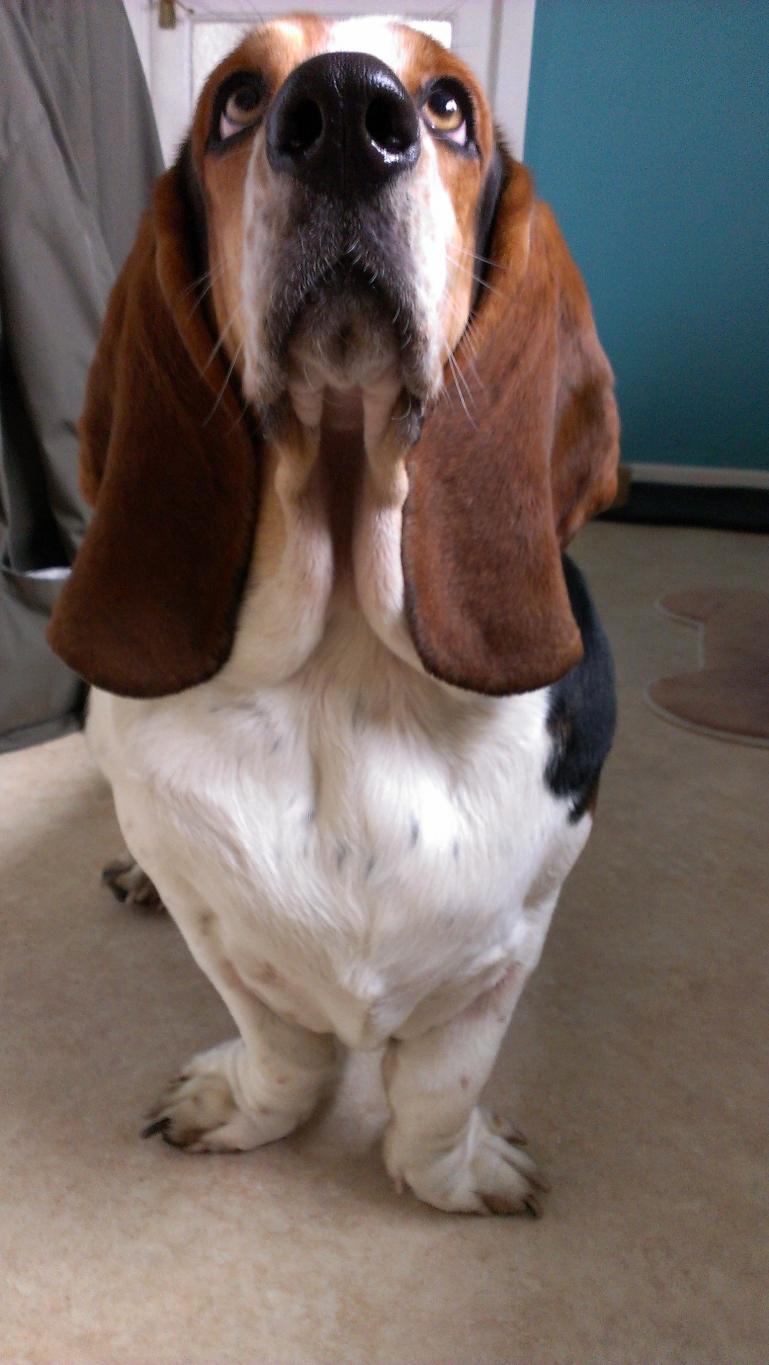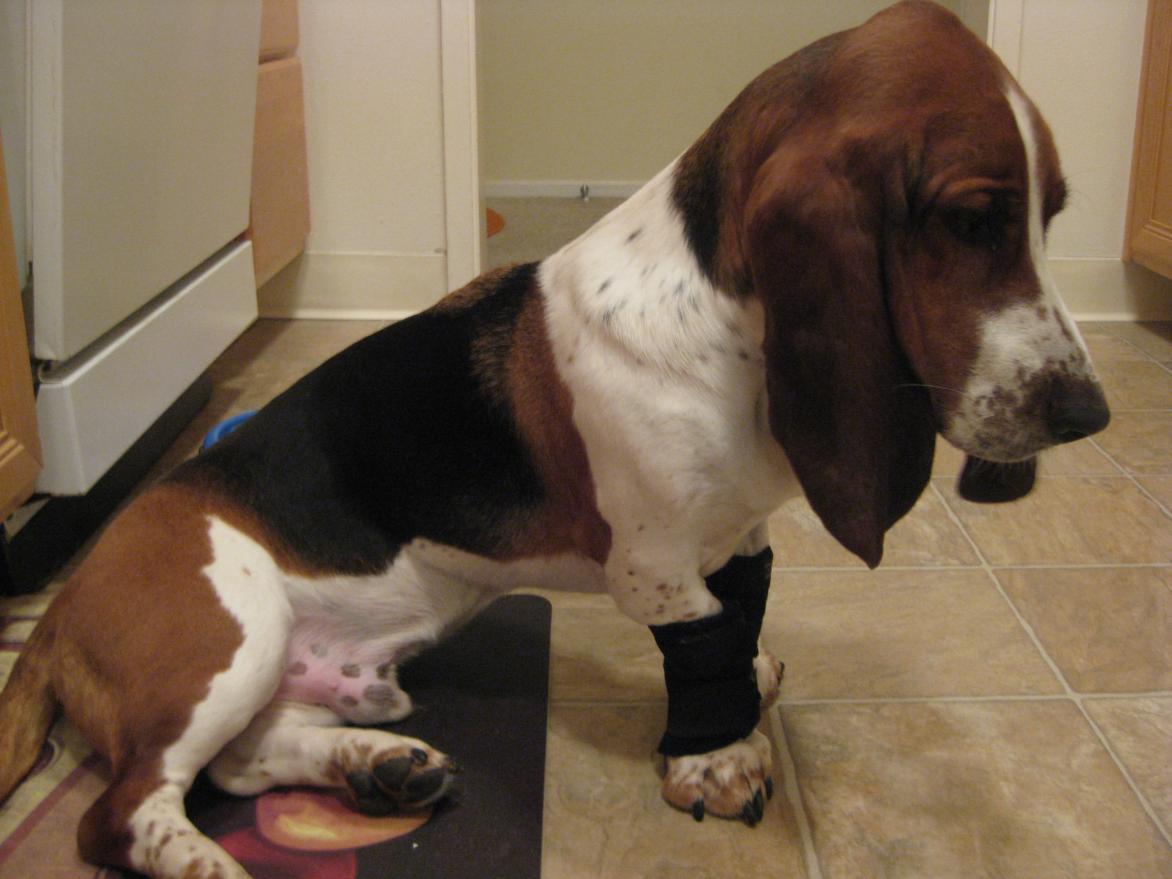The first image is the image on the left, the second image is the image on the right. Evaluate the accuracy of this statement regarding the images: "At least one dog is standing on the grass.". Is it true? Answer yes or no. No. The first image is the image on the left, the second image is the image on the right. For the images displayed, is the sentence "a dog is standing in the grass facing left'" factually correct? Answer yes or no. No. 